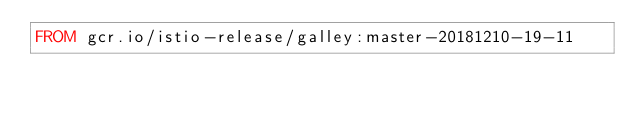<code> <loc_0><loc_0><loc_500><loc_500><_Dockerfile_>FROM gcr.io/istio-release/galley:master-20181210-19-11
</code> 